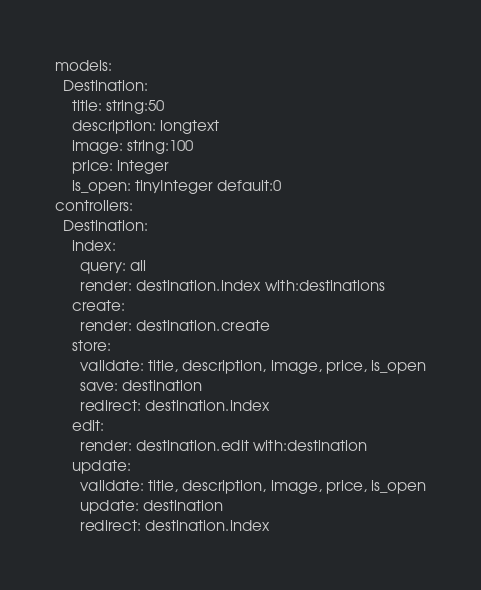Convert code to text. <code><loc_0><loc_0><loc_500><loc_500><_YAML_>models:
  Destination:
    title: string:50
    description: longtext
    image: string:100
    price: integer
    is_open: tinyInteger default:0
controllers:
  Destination:
    index:
      query: all
      render: destination.index with:destinations
    create:
      render: destination.create
    store:
      validate: title, description, image, price, is_open
      save: destination
      redirect: destination.index
    edit:
      render: destination.edit with:destination
    update:
      validate: title, description, image, price, is_open
      update: destination
      redirect: destination.index</code> 